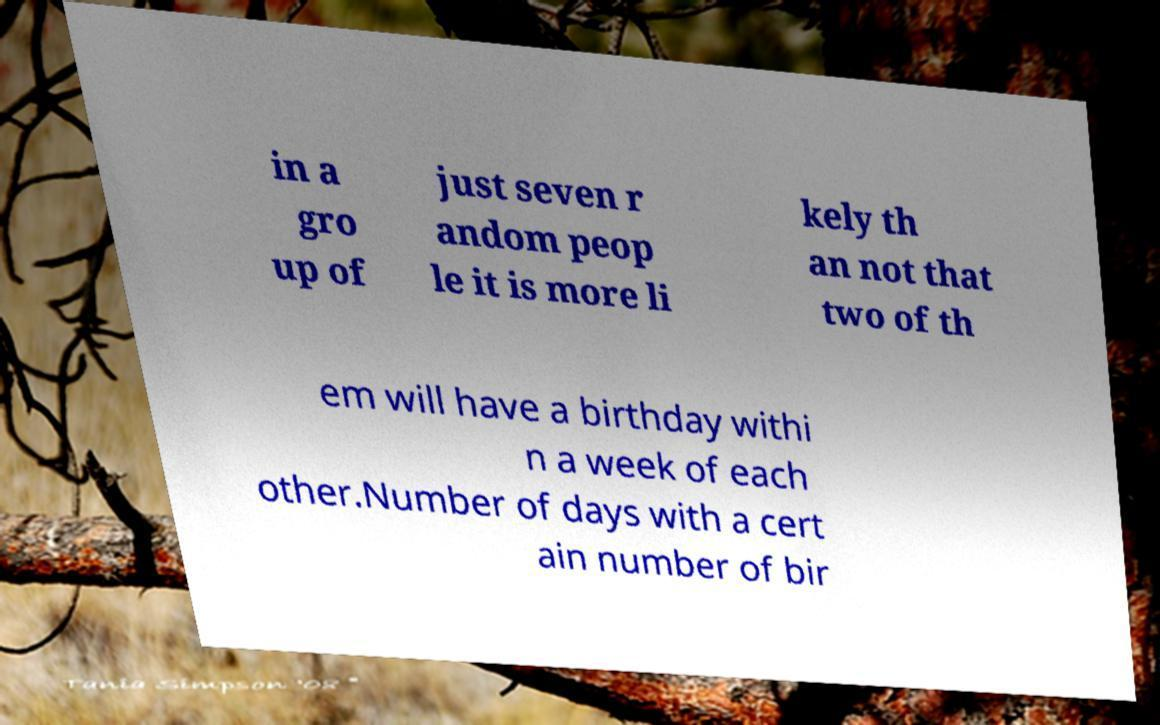Can you accurately transcribe the text from the provided image for me? in a gro up of just seven r andom peop le it is more li kely th an not that two of th em will have a birthday withi n a week of each other.Number of days with a cert ain number of bir 